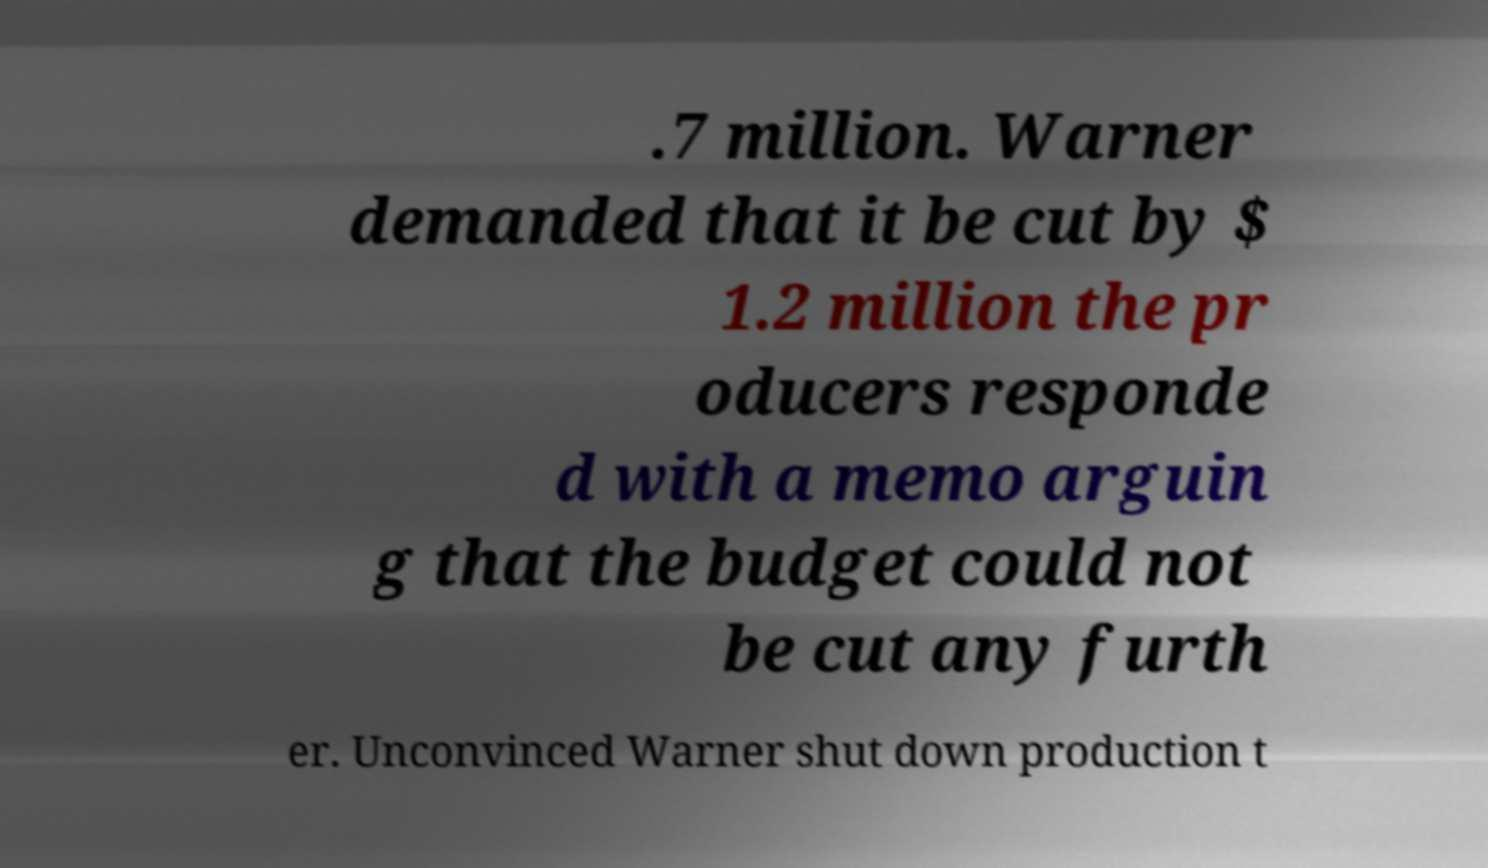Please identify and transcribe the text found in this image. .7 million. Warner demanded that it be cut by $ 1.2 million the pr oducers responde d with a memo arguin g that the budget could not be cut any furth er. Unconvinced Warner shut down production t 